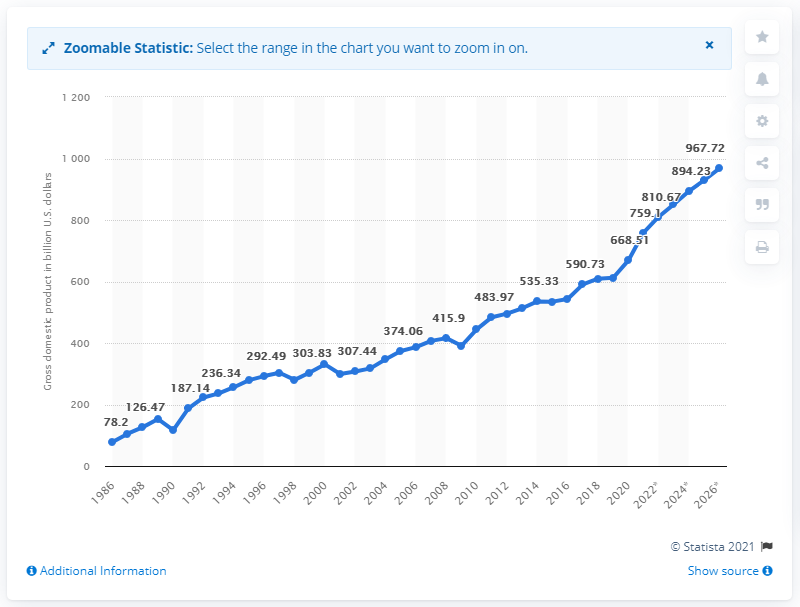What was Taiwan's gross domestic product in dollars in 2020? In 2020, Taiwan's gross domestic product was 668.51 billion U.S. dollars. The data illustrates a significant growth trend over the years, showing a steady increase in GDP. 